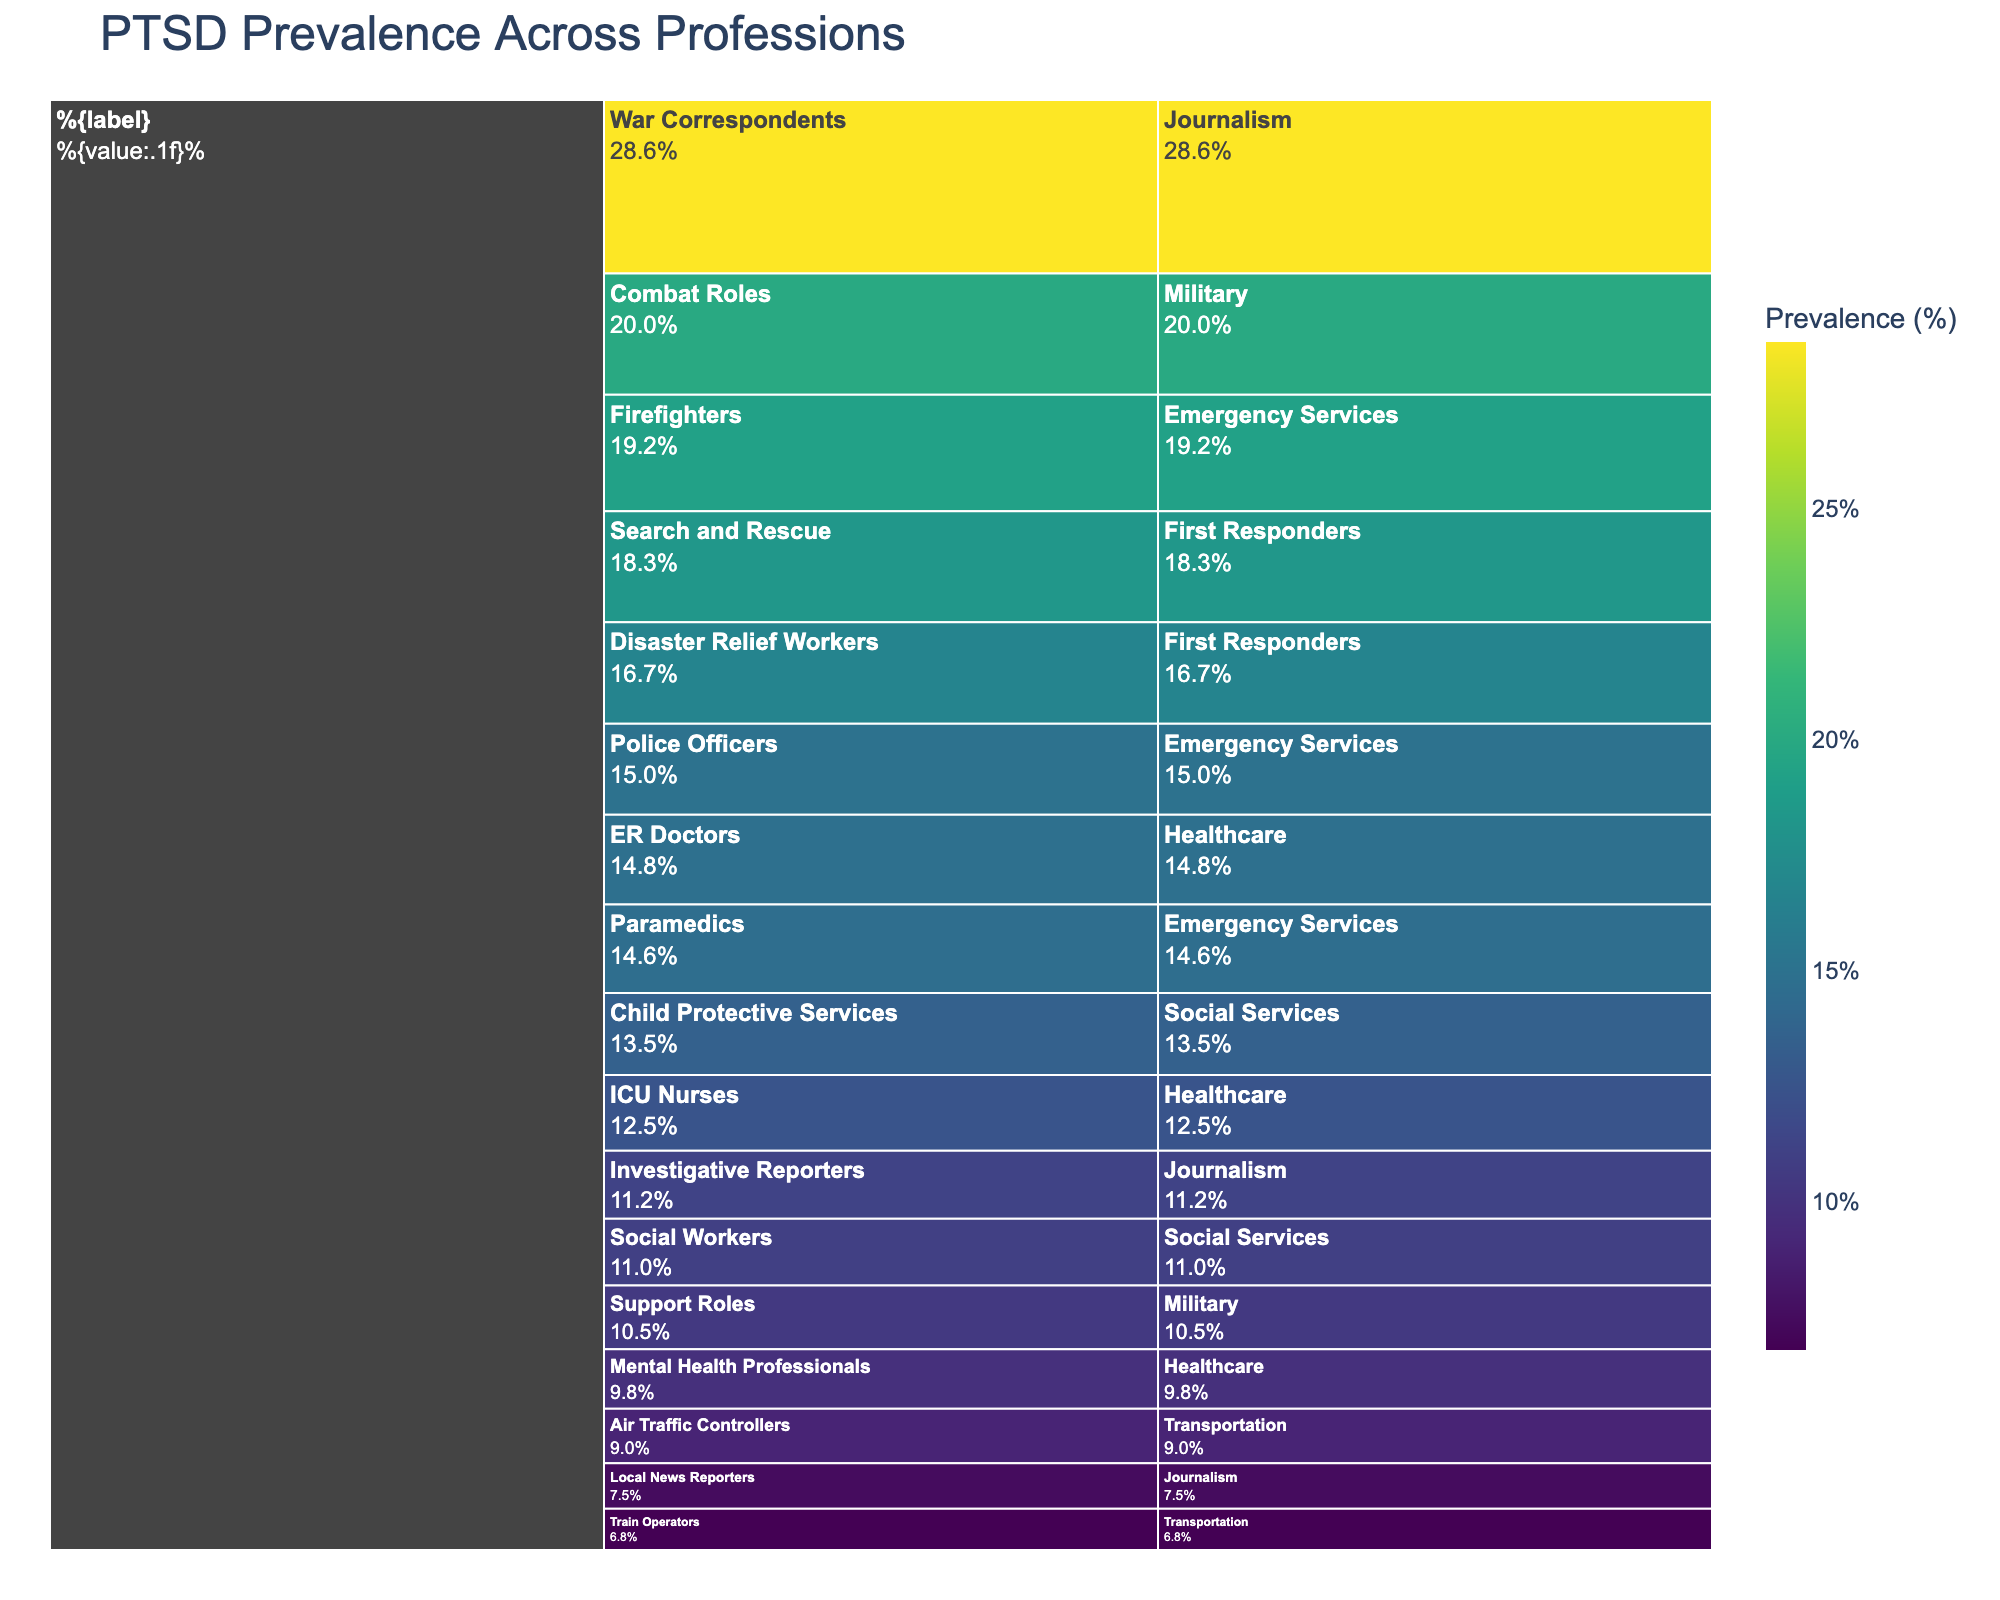What is the title of the chart? The text at the top of the chart indicates the headline or subject matter being depicted.
Answer: PTSD Prevalence Across Professions Which occupation has the highest PTSD prevalence? Look at the values in the chart and find the one with the highest percentage.
Answer: War Correspondents What is the PTSD prevalence for police officers? Locate the section of the chart related to Emergency Services and find Police Officers.
Answer: 15.0% How does the PTSD prevalence of ER Doctors compare to that of ICU Nurses? Find the values for ER Doctors and ICU Nurses and compare them. ER Doctors have 14.8% and ICU Nurses have 12.5%, so ER Doctors have a higher prevalence.
Answer: ER Doctors have a higher prevalence What is the average PTSD prevalence among the three professions listed under Healthcare? Add the prevalence values (14.8% + 12.5% + 9.8%) and divide by 3.
Answer: (14.8% + 12.5% + 9.8%) / 3 = 12.37% Which category has the highest overall PTSD prevalence: Emergency Services, Healthcare, or Journalism? Look at the prevalence values for each profession within these categories and identify the one with the highest values overall. Overall values suggest Journalism due to War Correspondents.
Answer: Journalism Compare the PTSD prevalence between Combat Roles in the Military and Search and Rescue in First Responders. The chart shows 20.0% for Combat Roles and 18.3% for Search and Rescue. Combat Roles have a higher prevalence.
Answer: Combat Roles have a higher prevalence What is the difference in PTSD prevalence between War Correspondents and Local News Reporters in Journalism? Subtract the prevalence value of Local News Reporters from that of War Correspondents (28.6% - 7.5%).
Answer: 28.6% - 7.5% = 21.1% Does the chart suggest that transportation-related occupations have higher or lower PTSD prevalence compared to social services? Review the PTSD prevalence for Transportation occupations (9.0% and 6.8%) and compare it with Social Services (13.5% and 11.0%). Social Services appears to have higher prevalence values.
Answer: Social Services have higher prevalence 